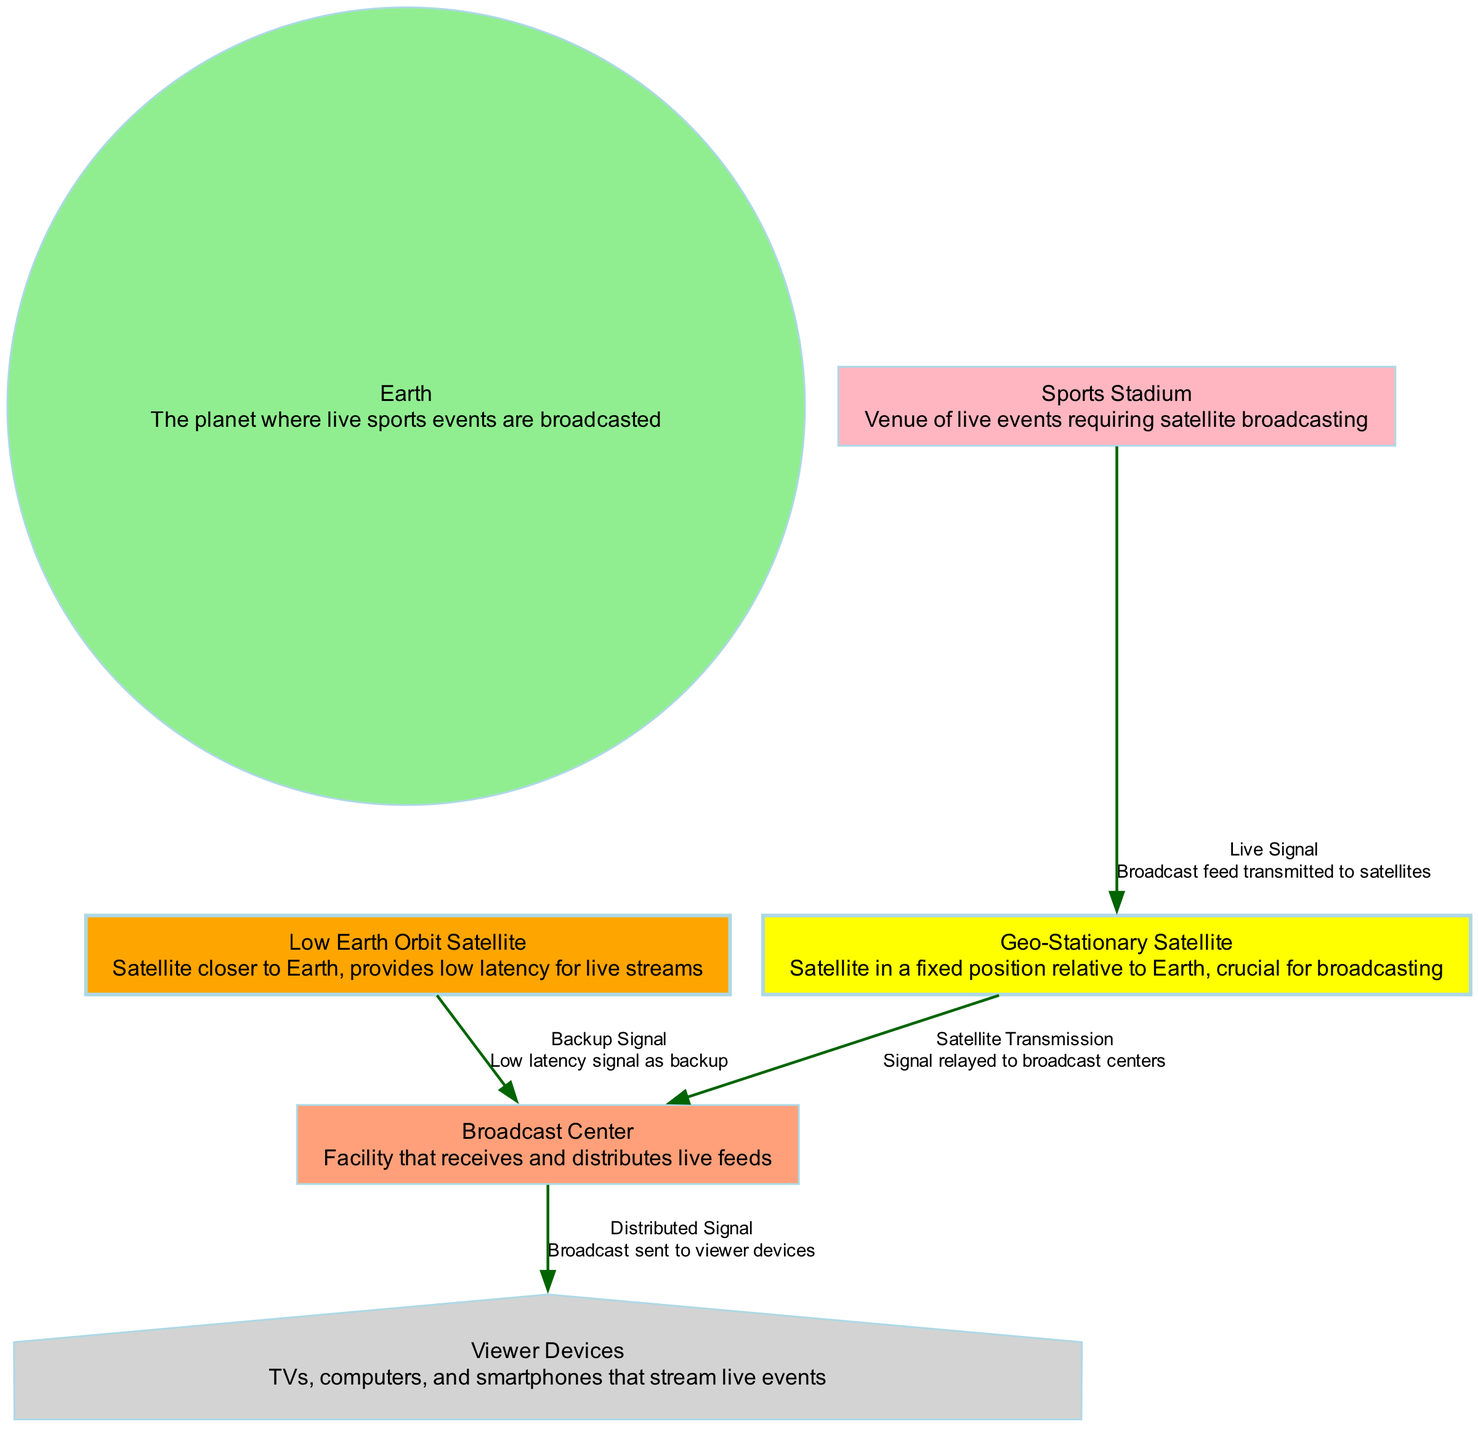What is the total number of nodes in the diagram? The diagram features six nodes: Earth, Geo-Stationary Satellite, Low Earth Orbit Satellite, Sports Stadium, Broadcast Center, and Viewer Devices. Counting each individual node confirms that there are a total of six.
Answer: 6 Which node is linked to the Geo-Stationary Satellite with a live signal? According to the diagram, the Sports Stadium is linked to the Geo-Stationary Satellite via a live signal relation. This link indicates that the broadcast feed is transmitted from the Sports Stadium to the Geo-Stationary Satellite.
Answer: Sports Stadium What type of satellite provides backup signals? The diagram specifies that the Low Earth Orbit Satellite provides backup signals. This satellite is denoted to have a relationship defined as a backup signal, especially for low latency.
Answer: Low Earth Orbit Satellite How is the signal relayed from the Geo-Stationary Satellite? The signal from the Geo-Stationary Satellite is relayed to the Broadcast Center. This indicates a one-directional relationship wherein the satellite transmits the signal directly to the broadcast facility.
Answer: Broadcast Center What color represents the Earth node in the diagram? In the diagram, the Earth node is represented in light green. This distinct coloration clearly differentiates it from other nodes and signifies its central role in the broadcasting hierarchy.
Answer: Light green If a viewer device wants to stream a live sports event, which component sends the distributed signal? The distributed signal, crucial for streaming live sports events to viewer devices, is sent from the Broadcast Center. This center is responsible for distributing the signals to various viewer devices.
Answer: Broadcast Center What is the main role of the Geo-Stationary Satellite? The main role of the Geo-Stationary Satellite, as indicated in the diagram, is broadcasting. It is positioned in a fixed location relative to Earth, which is essential for uninterrupted transmission of broadcasts.
Answer: Broadcasting What type of device receives the distributed signal from the Broadcast Center? The Viewer Devices are the ones that receive the distributed signal from the Broadcast Center. This encompasses a variety of devices like TVs, computers, and smartphones that allow viewers to access live sports events.
Answer: Viewer Devices Which two types of satellites are shown in the diagram? The diagram presents two types of satellites: Geo-Stationary Satellite and Low Earth Orbit Satellite. These satellites serve different functions in the broadcasting process, tailored to specific broadcasting needs.
Answer: Geo-Stationary Satellite and Low Earth Orbit Satellite 